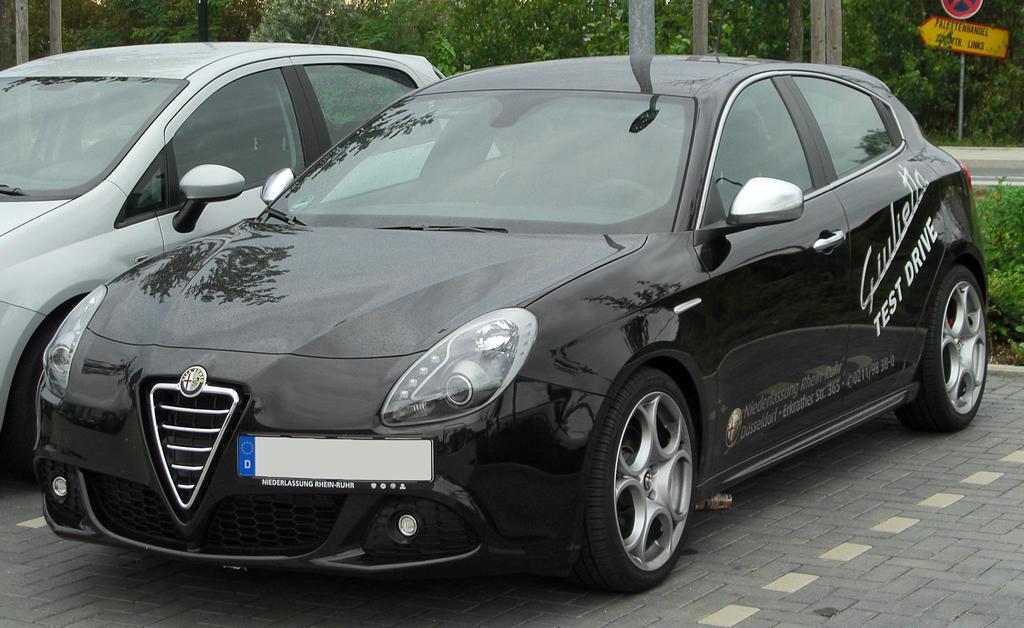How would you summarize this image in a sentence or two? In this picture we can observe two cars parked. There is a black color car and a grey color car. In the background there are trees and poles. On the right side we can observe boards fixed to this pole. 